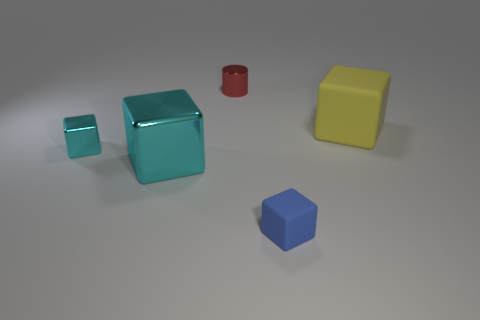How many big cyan metal cubes are there?
Offer a very short reply. 1. There is a rubber cube that is the same size as the red metal object; what color is it?
Your response must be concise. Blue. Is the small block that is on the left side of the tiny blue rubber thing made of the same material as the small thing that is to the right of the cylinder?
Offer a very short reply. No. How big is the cyan metal block that is to the right of the small shiny object left of the tiny metal cylinder?
Your answer should be very brief. Large. There is a cyan object behind the large cyan thing; what is it made of?
Your answer should be compact. Metal. How many objects are either tiny things that are right of the red cylinder or big things that are left of the blue thing?
Provide a short and direct response. 2. What is the material of the other tiny object that is the same shape as the small blue rubber object?
Your answer should be very brief. Metal. Does the tiny metallic thing that is in front of the shiny cylinder have the same color as the big thing that is left of the big yellow matte thing?
Give a very brief answer. Yes. Are there any blocks that have the same size as the yellow thing?
Your response must be concise. Yes. What material is the small thing that is left of the tiny matte thing and in front of the yellow block?
Offer a very short reply. Metal. 